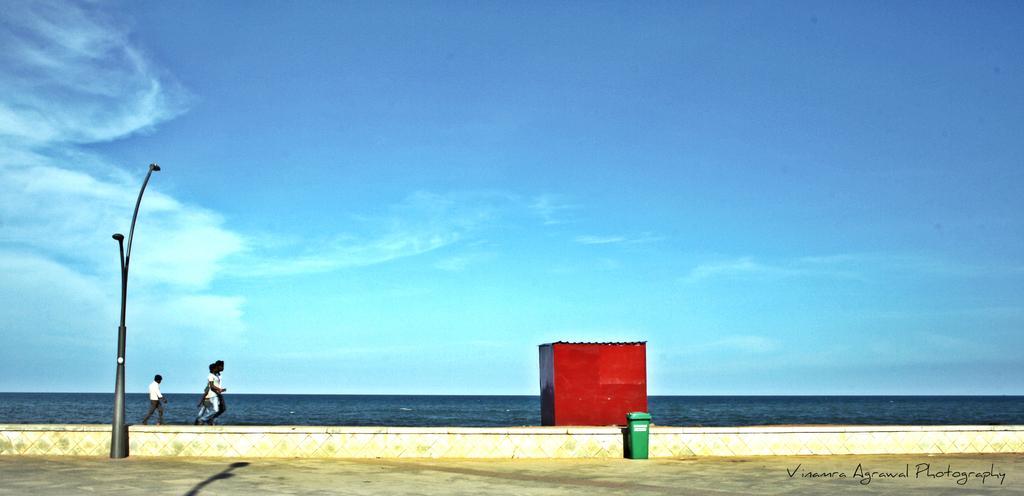How would you summarize this image in a sentence or two? On the left side of the image we can see a pole and group of people, in front of them we can see a shed and a dustbin, in the background we can find water and clouds, at the right bottom of the image we can see some text. 